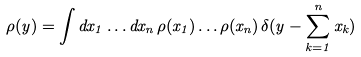<formula> <loc_0><loc_0><loc_500><loc_500>\rho ( y ) = \int d x _ { 1 } \dots d x _ { n } \, \rho ( x _ { 1 } ) \dots \rho ( x _ { n } ) \, \delta ( y - \sum _ { k = 1 } ^ { n } x _ { k } )</formula> 